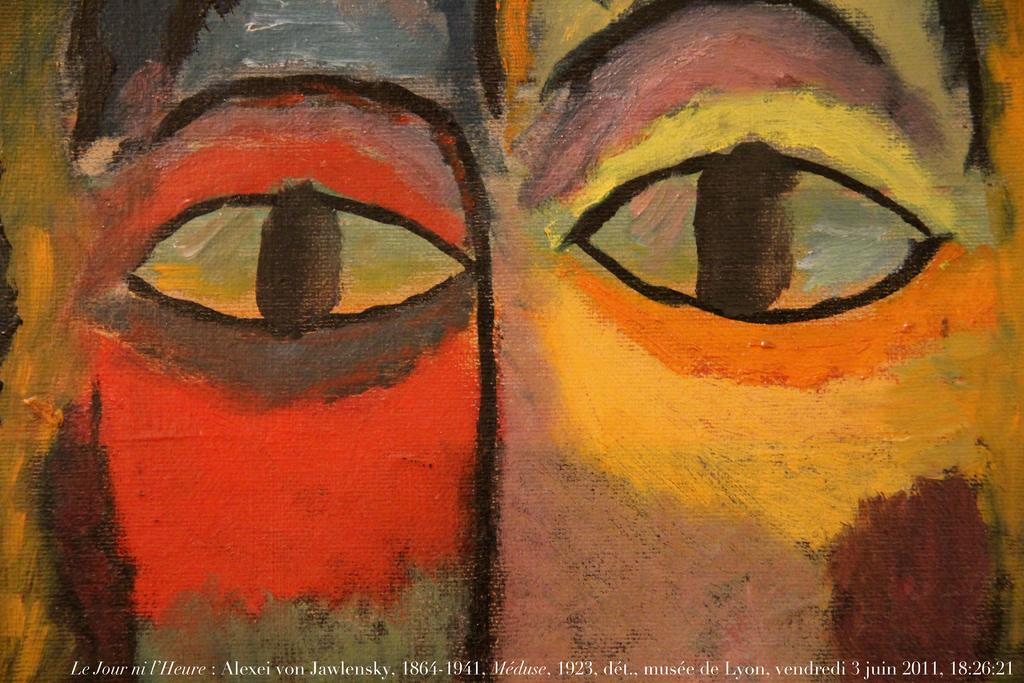What is the main subject of the painting in the image? The main subject of the painting in the image is a pair of eyes. Is there any text associated with the painting in the image? Yes, there is text written at the bottom side of the image. What type of texture can be seen on the frame of the painting in the image? There is no frame visible in the image, and therefore no texture can be observed on it. 